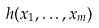Convert formula to latex. <formula><loc_0><loc_0><loc_500><loc_500>h ( x _ { 1 } , \dots , x _ { m } )</formula> 